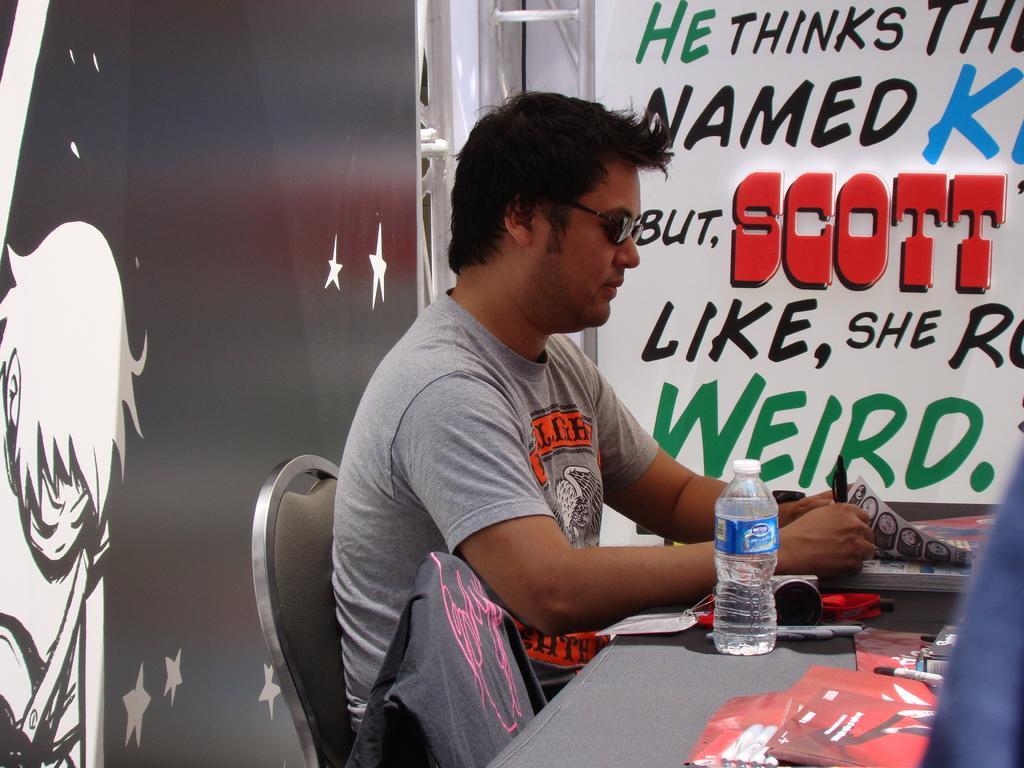Please provide a concise description of this image. In this image I can see the person sitting. In front I can see few papers, a bottle on the table. Background I can see a banner in white color and I can see something written on the banner. 